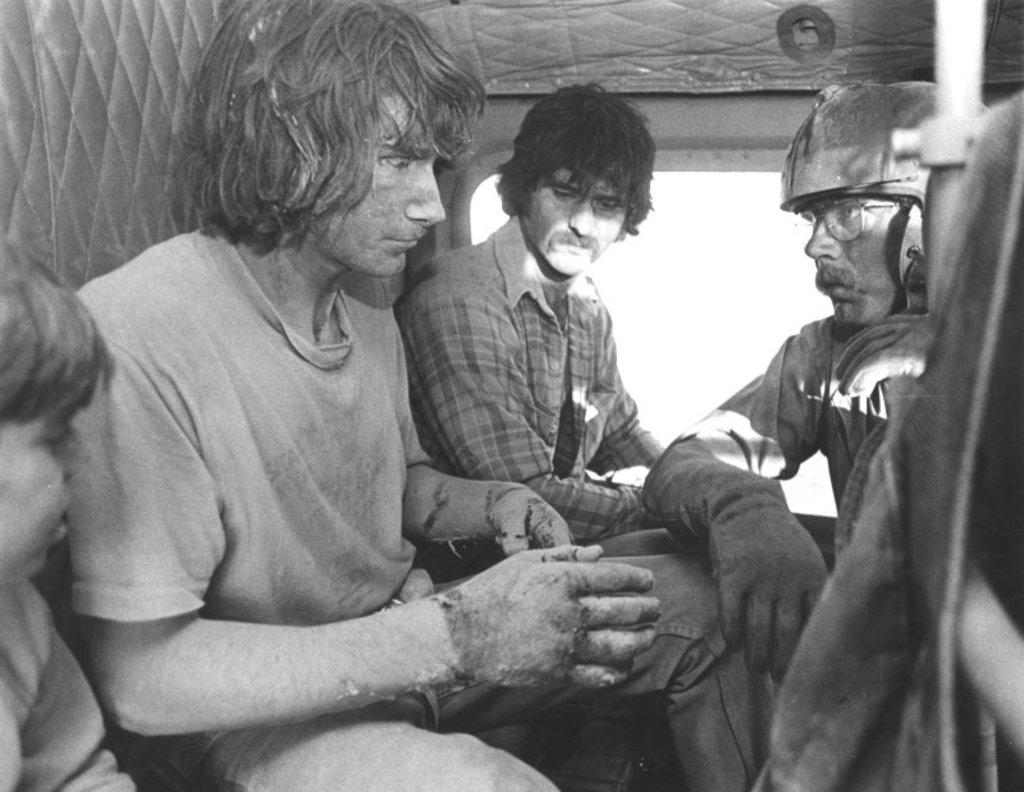Who or what can be seen in the image? There are people in the image. What objects are present in the image besides the people? There are rods in the image. What type of structure might the glass window be a part of? The glass window could be a part of a building or a vehicle. What type of calculator is being used by the fireman in the image? There is no fireman or calculator present in the image. 